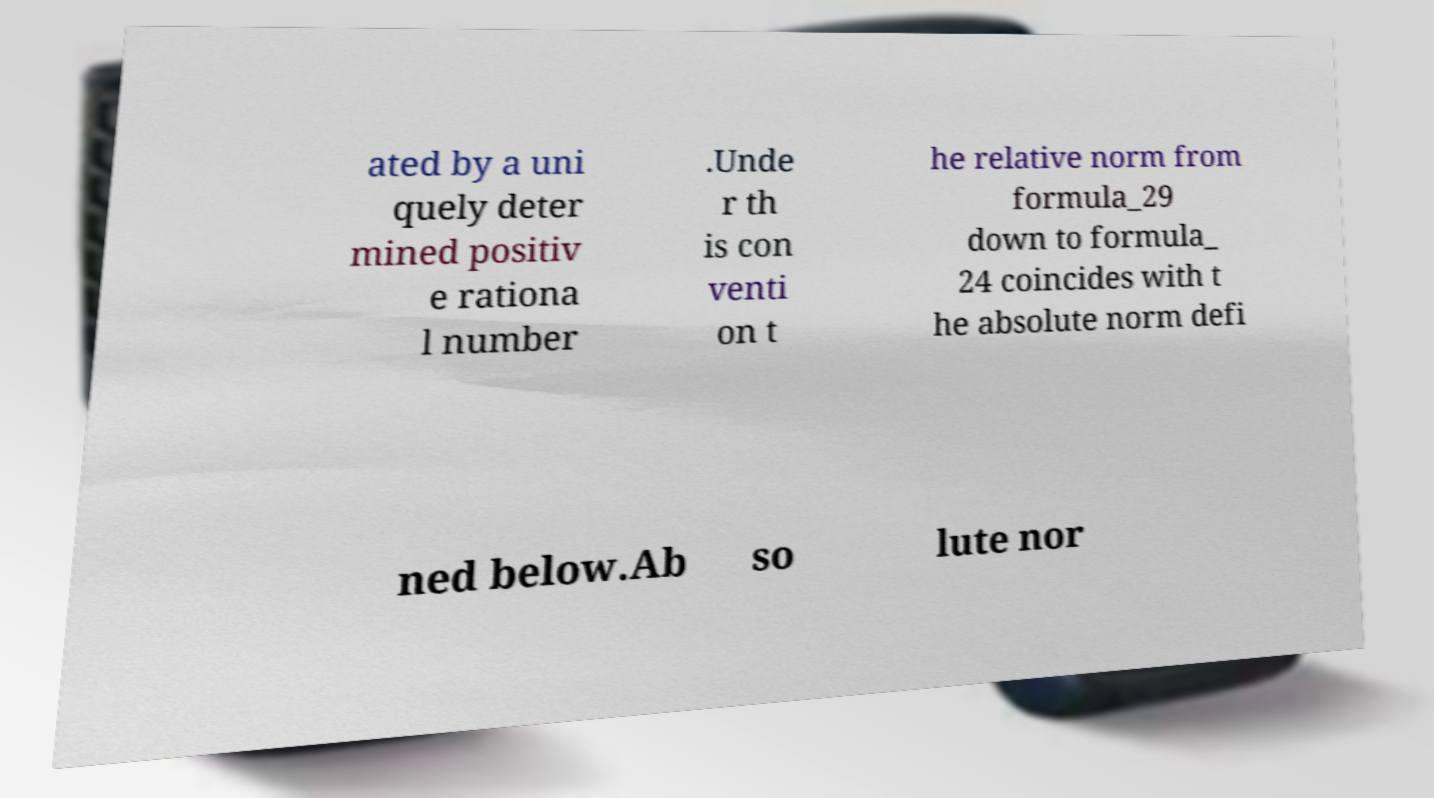What messages or text are displayed in this image? I need them in a readable, typed format. ated by a uni quely deter mined positiv e rationa l number .Unde r th is con venti on t he relative norm from formula_29 down to formula_ 24 coincides with t he absolute norm defi ned below.Ab so lute nor 